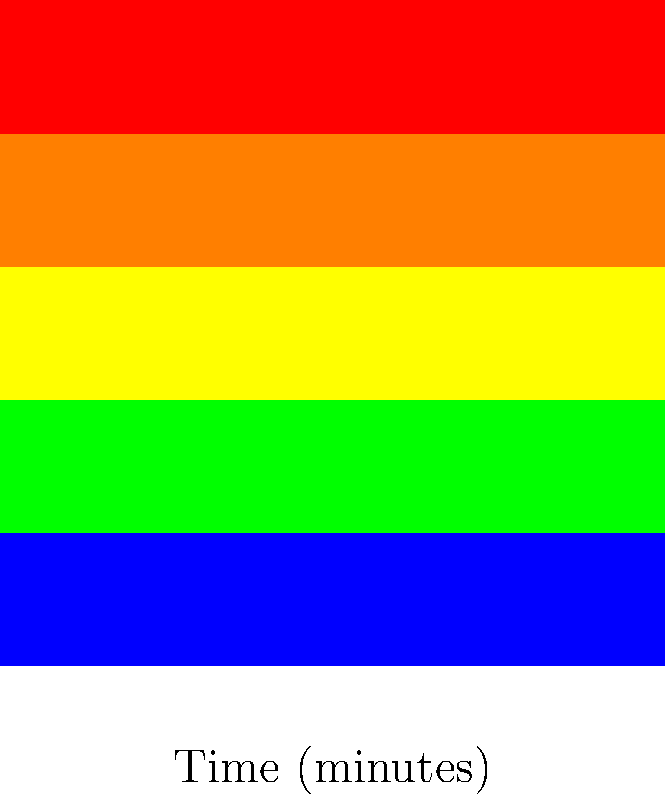Based on the heat map showing the spread of a fire over time and distance, estimate the rate at which the fire is spreading in meters per minute. Assume that the fire front is represented by the transition from orange to yellow (60°C). To estimate the fire spread rate, we need to follow these steps:

1. Identify the fire front: The question states that the fire front is represented by the transition from orange to yellow (60°C).

2. Determine the position of the fire front at different times:
   - At 0 minutes (bottom row), the fire front is at approximately 7.5 meters
   - At 20 minutes (top row), the fire front is at approximately 17.5 meters

3. Calculate the distance traveled:
   $\text{Distance} = 17.5 \text{ m} - 7.5 \text{ m} = 10 \text{ m}$

4. Calculate the time elapsed:
   $\text{Time} = 20 \text{ minutes} - 0 \text{ minutes} = 20 \text{ minutes}$

5. Calculate the spread rate:
   $$\text{Spread Rate} = \frac{\text{Distance}}{\text{Time}} = \frac{10 \text{ m}}{20 \text{ min}} = 0.5 \text{ m/min}$$

Therefore, the estimated fire spread rate is 0.5 meters per minute.
Answer: 0.5 m/min 